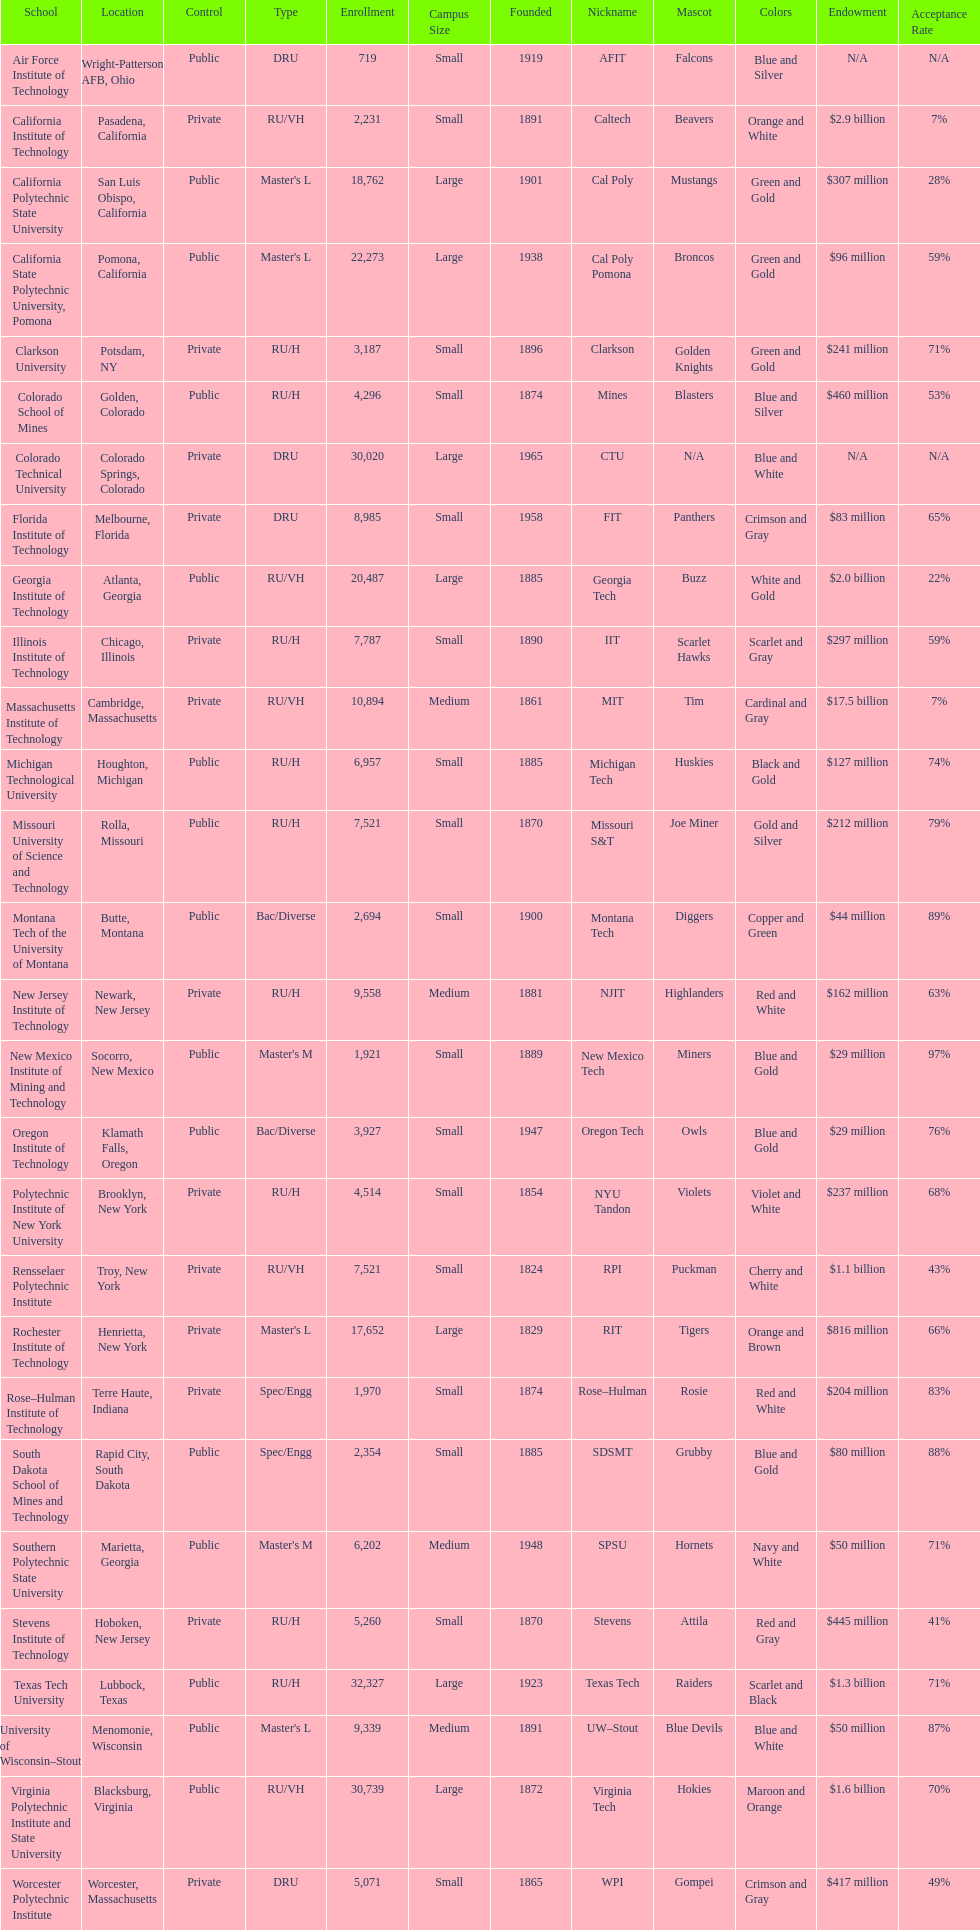Parse the full table. {'header': ['School', 'Location', 'Control', 'Type', 'Enrollment', 'Campus Size', 'Founded', 'Nickname', 'Mascot', 'Colors', 'Endowment', 'Acceptance Rate'], 'rows': [['Air Force Institute of Technology', 'Wright-Patterson AFB, Ohio', 'Public', 'DRU', '719', 'Small', '1919', 'AFIT', 'Falcons', 'Blue and Silver', 'N/A', 'N/A'], ['California Institute of Technology', 'Pasadena, California', 'Private', 'RU/VH', '2,231', 'Small', '1891', 'Caltech', 'Beavers', 'Orange and White', '$2.9 billion', '7%'], ['California Polytechnic State University', 'San Luis Obispo, California', 'Public', "Master's L", '18,762', 'Large', '1901', 'Cal Poly', 'Mustangs', 'Green and Gold', '$307 million', '28%'], ['California State Polytechnic University, Pomona', 'Pomona, California', 'Public', "Master's L", '22,273', 'Large', '1938', 'Cal Poly Pomona', 'Broncos', 'Green and Gold', '$96 million', '59%'], ['Clarkson University', 'Potsdam, NY', 'Private', 'RU/H', '3,187', 'Small', '1896', 'Clarkson', 'Golden Knights', 'Green and Gold', '$241 million', '71%'], ['Colorado School of Mines', 'Golden, Colorado', 'Public', 'RU/H', '4,296', 'Small', '1874', 'Mines', 'Blasters', 'Blue and Silver', '$460 million', '53%'], ['Colorado Technical University', 'Colorado Springs, Colorado', 'Private', 'DRU', '30,020', 'Large', '1965', 'CTU', 'N/A', 'Blue and White', 'N/A', 'N/A'], ['Florida Institute of Technology', 'Melbourne, Florida', 'Private', 'DRU', '8,985', 'Small', '1958', 'FIT', 'Panthers', 'Crimson and Gray', '$83 million', '65%'], ['Georgia Institute of Technology', 'Atlanta, Georgia', 'Public', 'RU/VH', '20,487', 'Large', '1885', 'Georgia Tech', 'Buzz', 'White and Gold', '$2.0 billion', '22%'], ['Illinois Institute of Technology', 'Chicago, Illinois', 'Private', 'RU/H', '7,787', 'Small', '1890', 'IIT', 'Scarlet Hawks', 'Scarlet and Gray', '$297 million', '59%'], ['Massachusetts Institute of Technology', 'Cambridge, Massachusetts', 'Private', 'RU/VH', '10,894', 'Medium', '1861', 'MIT', 'Tim', 'Cardinal and Gray', '$17.5 billion', '7%'], ['Michigan Technological University', 'Houghton, Michigan', 'Public', 'RU/H', '6,957', 'Small', '1885', 'Michigan Tech', 'Huskies', 'Black and Gold', '$127 million', '74%'], ['Missouri University of Science and Technology', 'Rolla, Missouri', 'Public', 'RU/H', '7,521', 'Small', '1870', 'Missouri S&T', 'Joe Miner', 'Gold and Silver', '$212 million', '79%'], ['Montana Tech of the University of Montana', 'Butte, Montana', 'Public', 'Bac/Diverse', '2,694', 'Small', '1900', 'Montana Tech', 'Diggers', 'Copper and Green', '$44 million', '89%'], ['New Jersey Institute of Technology', 'Newark, New Jersey', 'Private', 'RU/H', '9,558', 'Medium', '1881', 'NJIT', 'Highlanders', 'Red and White', '$162 million', '63%'], ['New Mexico Institute of Mining and Technology', 'Socorro, New Mexico', 'Public', "Master's M", '1,921', 'Small', '1889', 'New Mexico Tech', 'Miners', 'Blue and Gold', '$29 million', '97%'], ['Oregon Institute of Technology', 'Klamath Falls, Oregon', 'Public', 'Bac/Diverse', '3,927', 'Small', '1947', 'Oregon Tech', 'Owls', 'Blue and Gold', '$29 million', '76%'], ['Polytechnic Institute of New York University', 'Brooklyn, New York', 'Private', 'RU/H', '4,514', 'Small', '1854', 'NYU Tandon', 'Violets', 'Violet and White', '$237 million', '68%'], ['Rensselaer Polytechnic Institute', 'Troy, New York', 'Private', 'RU/VH', '7,521', 'Small', '1824', 'RPI', 'Puckman', 'Cherry and White', '$1.1 billion', '43%'], ['Rochester Institute of Technology', 'Henrietta, New York', 'Private', "Master's L", '17,652', 'Large', '1829', 'RIT', 'Tigers', 'Orange and Brown', '$816 million', '66%'], ['Rose–Hulman Institute of Technology', 'Terre Haute, Indiana', 'Private', 'Spec/Engg', '1,970', 'Small', '1874', 'Rose–Hulman', 'Rosie', 'Red and White', '$204 million', '83%'], ['South Dakota School of Mines and Technology', 'Rapid City, South Dakota', 'Public', 'Spec/Engg', '2,354', 'Small', '1885', 'SDSMT', 'Grubby', 'Blue and Gold', '$80 million', '88%'], ['Southern Polytechnic State University', 'Marietta, Georgia', 'Public', "Master's M", '6,202', 'Medium', '1948', 'SPSU', 'Hornets', 'Navy and White', '$50 million', '71%'], ['Stevens Institute of Technology', 'Hoboken, New Jersey', 'Private', 'RU/H', '5,260', 'Small', '1870', 'Stevens', 'Attila', 'Red and Gray', '$445 million', '41%'], ['Texas Tech University', 'Lubbock, Texas', 'Public', 'RU/H', '32,327', 'Large', '1923', 'Texas Tech', 'Raiders', 'Scarlet and Black', '$1.3 billion', '71%'], ['University of Wisconsin–Stout', 'Menomonie, Wisconsin', 'Public', "Master's L", '9,339', 'Medium', '1891', 'UW–Stout', 'Blue Devils', 'Blue and White', '$50 million', '87%'], ['Virginia Polytechnic Institute and State University', 'Blacksburg, Virginia', 'Public', 'RU/VH', '30,739', 'Large', '1872', 'Virginia Tech', 'Hokies', 'Maroon and Orange', '$1.6 billion', '70%'], ['Worcester Polytechnic Institute', 'Worcester, Massachusetts', 'Private', 'DRU', '5,071', 'Small', '1865', 'WPI', 'Gompei', 'Crimson and Gray', '$417 million', '49%']]} Which of the universities was founded first? Rensselaer Polytechnic Institute. 